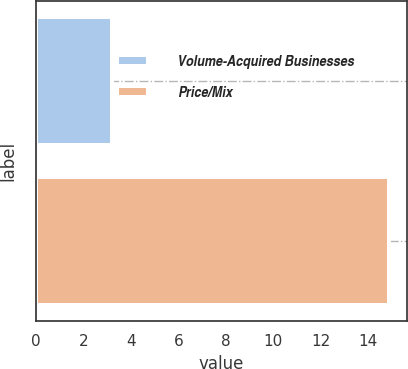Convert chart. <chart><loc_0><loc_0><loc_500><loc_500><bar_chart><fcel>Volume-Acquired Businesses<fcel>Price/Mix<nl><fcel>3.2<fcel>14.9<nl></chart> 